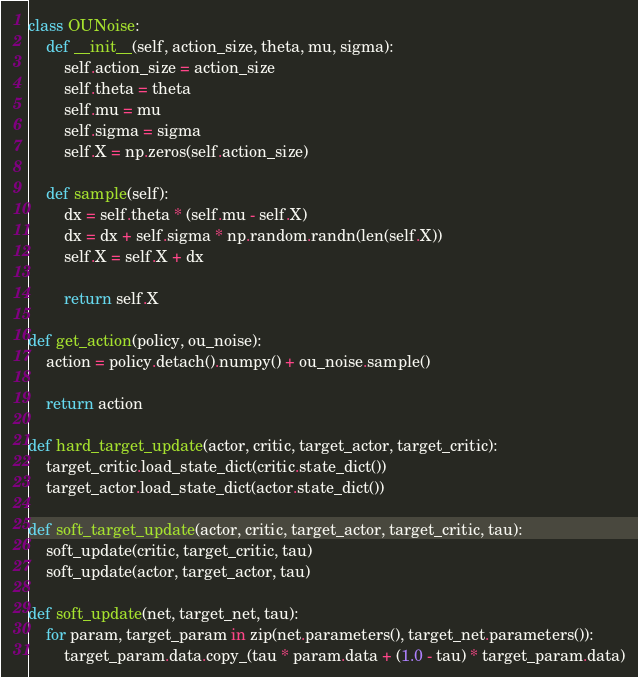<code> <loc_0><loc_0><loc_500><loc_500><_Python_>class OUNoise:
    def __init__(self, action_size, theta, mu, sigma):
        self.action_size = action_size
        self.theta = theta
        self.mu = mu
        self.sigma = sigma
        self.X = np.zeros(self.action_size) 

    def sample(self):
        dx = self.theta * (self.mu - self.X)
        dx = dx + self.sigma * np.random.randn(len(self.X))
        self.X = self.X + dx
        
        return self.X

def get_action(policy, ou_noise): 
    action = policy.detach().numpy() + ou_noise.sample() 

    return action

def hard_target_update(actor, critic, target_actor, target_critic):
    target_critic.load_state_dict(critic.state_dict())
    target_actor.load_state_dict(actor.state_dict())

def soft_target_update(actor, critic, target_actor, target_critic, tau):
    soft_update(critic, target_critic, tau)
    soft_update(actor, target_actor, tau)

def soft_update(net, target_net, tau):
    for param, target_param in zip(net.parameters(), target_net.parameters()):
        target_param.data.copy_(tau * param.data + (1.0 - tau) * target_param.data)</code> 